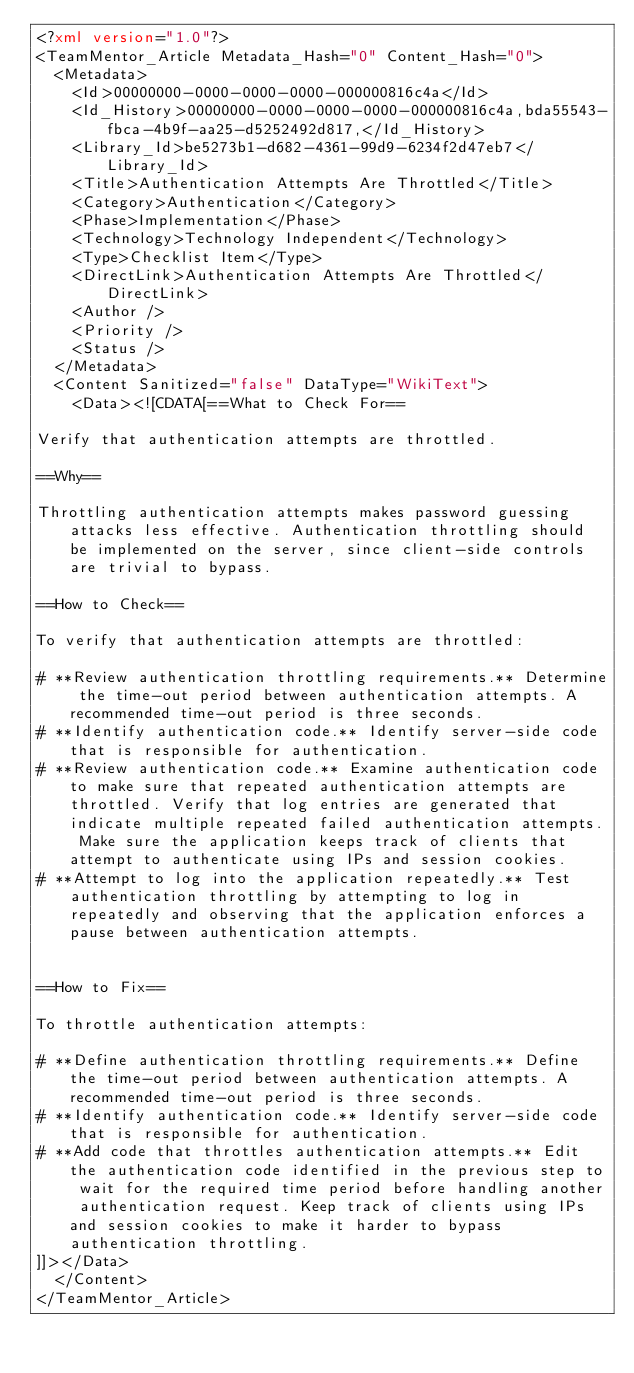<code> <loc_0><loc_0><loc_500><loc_500><_XML_><?xml version="1.0"?>
<TeamMentor_Article Metadata_Hash="0" Content_Hash="0">
  <Metadata>
    <Id>00000000-0000-0000-0000-000000816c4a</Id>
    <Id_History>00000000-0000-0000-0000-000000816c4a,bda55543-fbca-4b9f-aa25-d5252492d817,</Id_History>
    <Library_Id>be5273b1-d682-4361-99d9-6234f2d47eb7</Library_Id>
    <Title>Authentication Attempts Are Throttled</Title>
    <Category>Authentication</Category>
    <Phase>Implementation</Phase>
    <Technology>Technology Independent</Technology>
    <Type>Checklist Item</Type>
    <DirectLink>Authentication Attempts Are Throttled</DirectLink>
    <Author />
    <Priority />
    <Status />
  </Metadata>
  <Content Sanitized="false" DataType="WikiText">
    <Data><![CDATA[==What to Check For==

Verify that authentication attempts are throttled.

==Why==

Throttling authentication attempts makes password guessing attacks less effective. Authentication throttling should be implemented on the server, since client-side controls are trivial to bypass.

==How to Check==

To verify that authentication attempts are throttled:

# **Review authentication throttling requirements.** Determine the time-out period between authentication attempts. A recommended time-out period is three seconds.
# **Identify authentication code.** Identify server-side code that is responsible for authentication.
# **Review authentication code.** Examine authentication code to make sure that repeated authentication attempts are throttled. Verify that log entries are generated that indicate multiple repeated failed authentication attempts. Make sure the application keeps track of clients that attempt to authenticate using IPs and session cookies.
# **Attempt to log into the application repeatedly.** Test authentication throttling by attempting to log in repeatedly and observing that the application enforces a pause between authentication attempts.


==How to Fix==

To throttle authentication attempts:

# **Define authentication throttling requirements.** Define the time-out period between authentication attempts. A recommended time-out period is three seconds.
# **Identify authentication code.** Identify server-side code that is responsible for authentication.
# **Add code that throttles authentication attempts.** Edit the authentication code identified in the previous step to wait for the required time period before handling another authentication request. Keep track of clients using IPs and session cookies to make it harder to bypass authentication throttling.
]]></Data>
  </Content>
</TeamMentor_Article></code> 